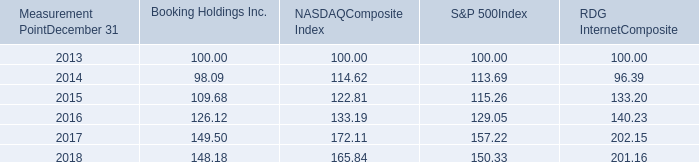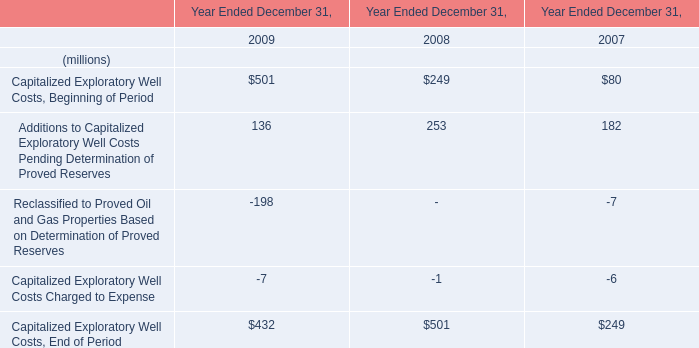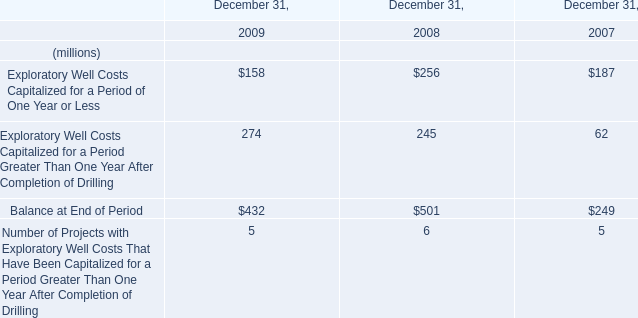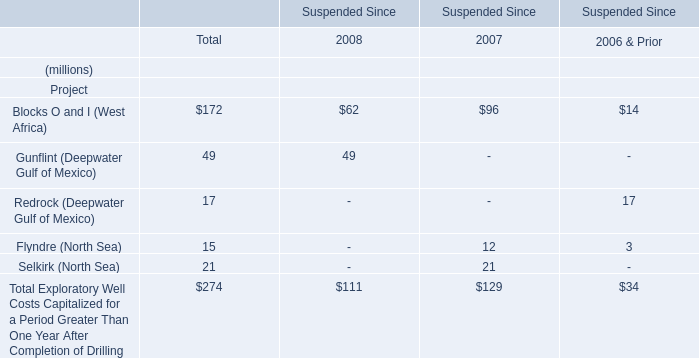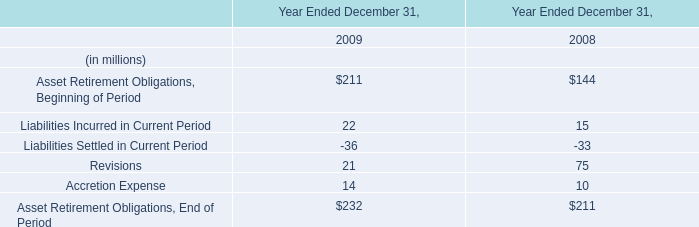Which year is Exploratory Well Costs Capitalized for a Period of One Year or Less the least? 
Answer: 2009. 